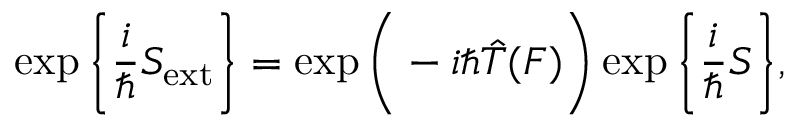Convert formula to latex. <formula><loc_0><loc_0><loc_500><loc_500>\exp \left \{ \frac { i } { } S _ { e x t } \right \} = \exp \left ( - i \hbar { \hat } { T } ( F ) \right ) \exp \left \{ \frac { i } { } S \right \} ,</formula> 